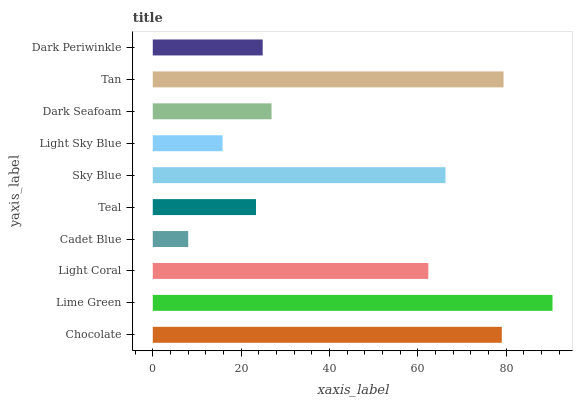Is Cadet Blue the minimum?
Answer yes or no. Yes. Is Lime Green the maximum?
Answer yes or no. Yes. Is Light Coral the minimum?
Answer yes or no. No. Is Light Coral the maximum?
Answer yes or no. No. Is Lime Green greater than Light Coral?
Answer yes or no. Yes. Is Light Coral less than Lime Green?
Answer yes or no. Yes. Is Light Coral greater than Lime Green?
Answer yes or no. No. Is Lime Green less than Light Coral?
Answer yes or no. No. Is Light Coral the high median?
Answer yes or no. Yes. Is Dark Seafoam the low median?
Answer yes or no. Yes. Is Chocolate the high median?
Answer yes or no. No. Is Lime Green the low median?
Answer yes or no. No. 